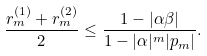<formula> <loc_0><loc_0><loc_500><loc_500>\frac { r _ { m } ^ { ( 1 ) } + r _ { m } ^ { ( 2 ) } } { 2 } \leq \frac { 1 - | \alpha \beta | } { 1 - | \alpha | ^ { m } | p _ { m } | } .</formula> 